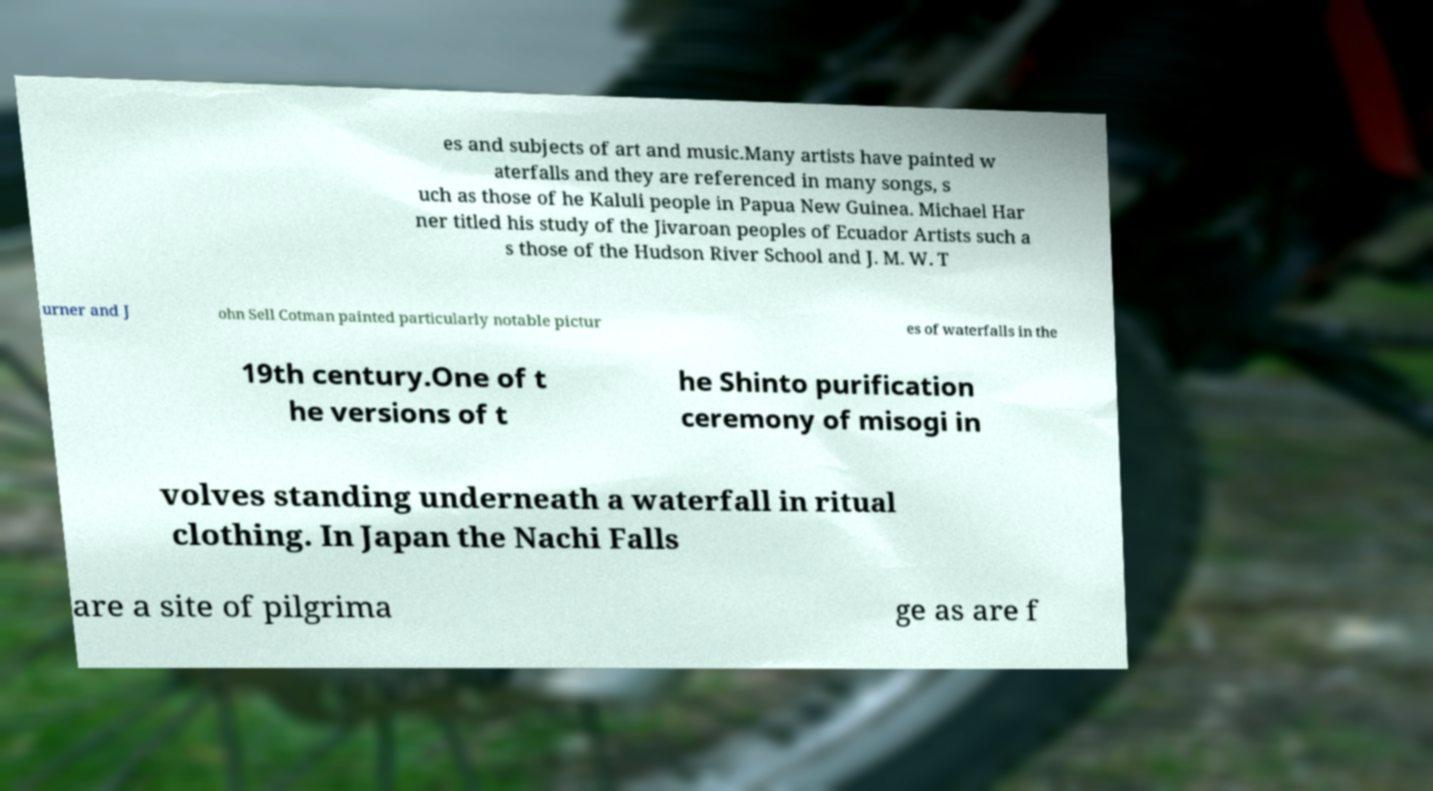Please read and relay the text visible in this image. What does it say? es and subjects of art and music.Many artists have painted w aterfalls and they are referenced in many songs, s uch as those of he Kaluli people in Papua New Guinea. Michael Har ner titled his study of the Jivaroan peoples of Ecuador Artists such a s those of the Hudson River School and J. M. W. T urner and J ohn Sell Cotman painted particularly notable pictur es of waterfalls in the 19th century.One of t he versions of t he Shinto purification ceremony of misogi in volves standing underneath a waterfall in ritual clothing. In Japan the Nachi Falls are a site of pilgrima ge as are f 